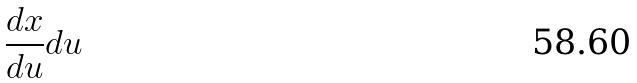Convert formula to latex. <formula><loc_0><loc_0><loc_500><loc_500>\frac { d x } { d u } d u</formula> 